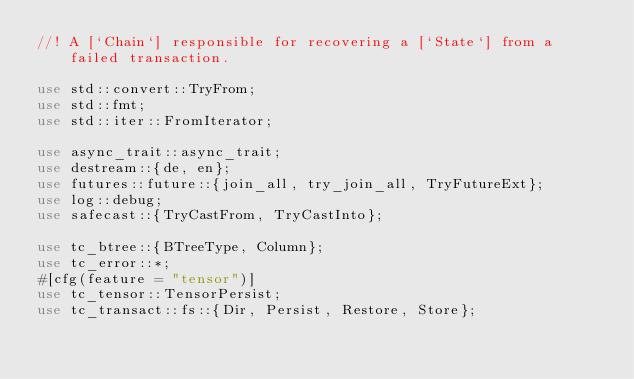Convert code to text. <code><loc_0><loc_0><loc_500><loc_500><_Rust_>//! A [`Chain`] responsible for recovering a [`State`] from a failed transaction.

use std::convert::TryFrom;
use std::fmt;
use std::iter::FromIterator;

use async_trait::async_trait;
use destream::{de, en};
use futures::future::{join_all, try_join_all, TryFutureExt};
use log::debug;
use safecast::{TryCastFrom, TryCastInto};

use tc_btree::{BTreeType, Column};
use tc_error::*;
#[cfg(feature = "tensor")]
use tc_tensor::TensorPersist;
use tc_transact::fs::{Dir, Persist, Restore, Store};</code> 